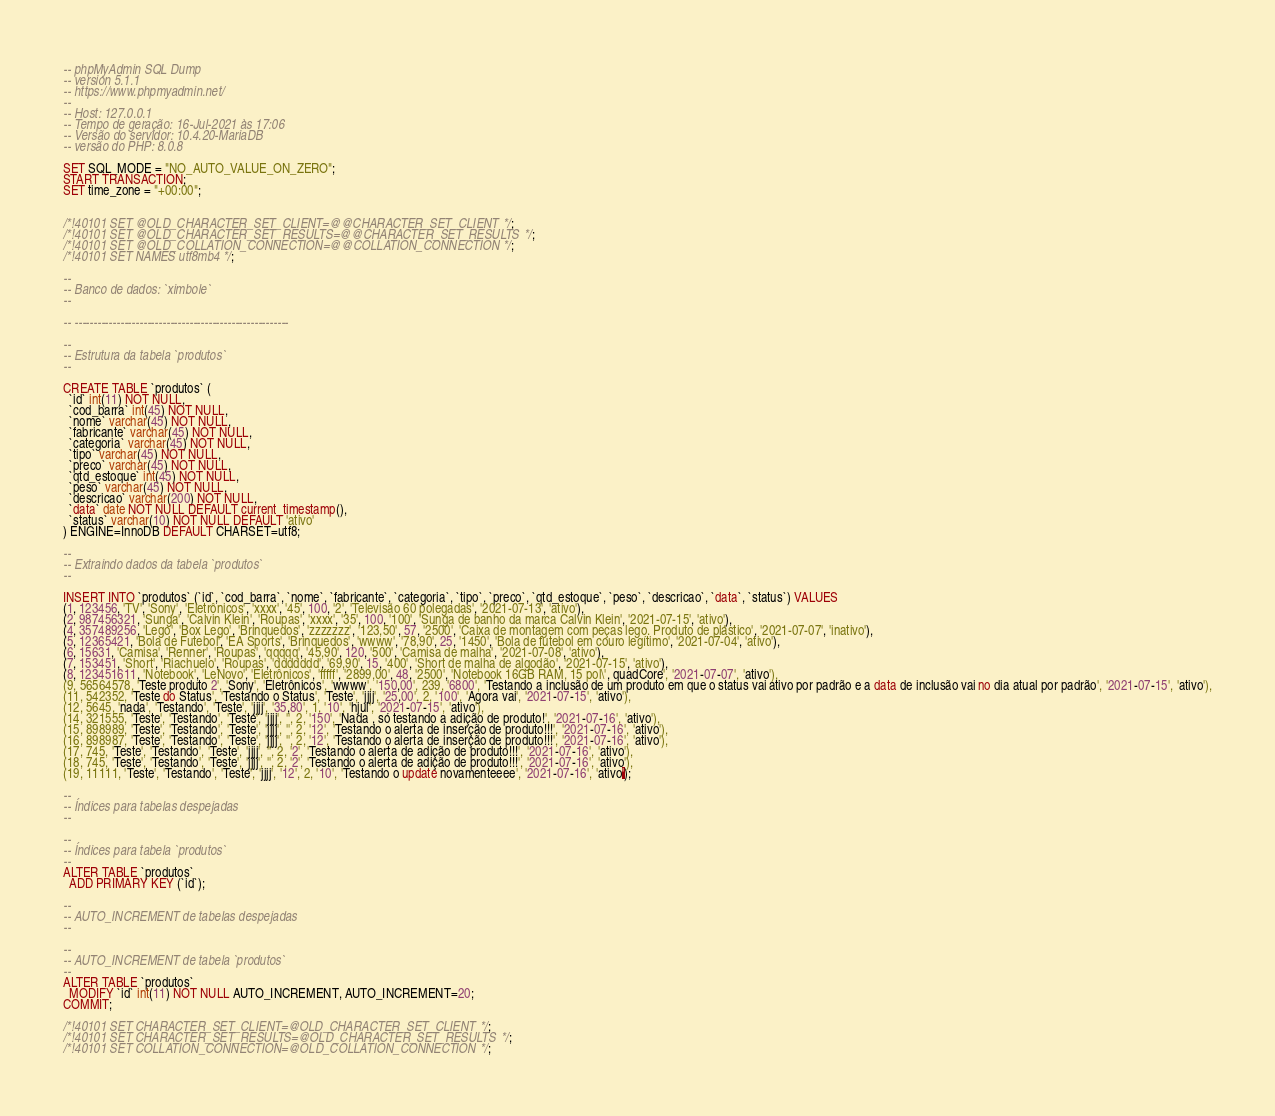Convert code to text. <code><loc_0><loc_0><loc_500><loc_500><_SQL_>-- phpMyAdmin SQL Dump
-- version 5.1.1
-- https://www.phpmyadmin.net/
--
-- Host: 127.0.0.1
-- Tempo de geração: 16-Jul-2021 às 17:06
-- Versão do servidor: 10.4.20-MariaDB
-- versão do PHP: 8.0.8

SET SQL_MODE = "NO_AUTO_VALUE_ON_ZERO";
START TRANSACTION;
SET time_zone = "+00:00";


/*!40101 SET @OLD_CHARACTER_SET_CLIENT=@@CHARACTER_SET_CLIENT */;
/*!40101 SET @OLD_CHARACTER_SET_RESULTS=@@CHARACTER_SET_RESULTS */;
/*!40101 SET @OLD_COLLATION_CONNECTION=@@COLLATION_CONNECTION */;
/*!40101 SET NAMES utf8mb4 */;

--
-- Banco de dados: `ximbole`
--

-- --------------------------------------------------------

--
-- Estrutura da tabela `produtos`
--

CREATE TABLE `produtos` (
  `id` int(11) NOT NULL,
  `cod_barra` int(45) NOT NULL,
  `nome` varchar(45) NOT NULL,
  `fabricante` varchar(45) NOT NULL,
  `categoria` varchar(45) NOT NULL,
  `tipo` varchar(45) NOT NULL,
  `preco` varchar(45) NOT NULL,
  `qtd_estoque` int(45) NOT NULL,
  `peso` varchar(45) NOT NULL,
  `descricao` varchar(200) NOT NULL,
  `data` date NOT NULL DEFAULT current_timestamp(),
  `status` varchar(10) NOT NULL DEFAULT 'ativo'
) ENGINE=InnoDB DEFAULT CHARSET=utf8;

--
-- Extraindo dados da tabela `produtos`
--

INSERT INTO `produtos` (`id`, `cod_barra`, `nome`, `fabricante`, `categoria`, `tipo`, `preco`, `qtd_estoque`, `peso`, `descricao`, `data`, `status`) VALUES
(1, 123456, 'TV', 'Sony', 'Eletrônicos', 'xxxx', '45', 100, '2', 'Televisão 60 polegadas', '2021-07-13', 'ativo'),
(2, 987456321, 'Sunga', 'Calvin Klein', 'Roupas', 'xxxx', '35', 100, '100', 'Sunga de banho da marca Calvin Klein', '2021-07-15', 'ativo'),
(4, 357489256, 'Lego', 'Box Lego', 'Brinquedos', 'zzzzzzz', '123,50', 57, '2500', 'Caixa de montagem com peças lego. Produto de plástico', '2021-07-07', 'inativo'),
(5, 12365421, 'Bola de Futebol', 'EA Sports', 'Brinquedos', 'wwww', '78,90', 25, '1450', 'Bola de futebol em couro legítimo', '2021-07-04', 'ativo'),
(6, 15631, 'Camisa', 'Renner', 'Roupas', 'qqqqq', '45,90', 120, '500', 'Camisa de malha', '2021-07-08', 'ativo'),
(7, 153451, 'Short', 'Riachuelo', 'Roupas', 'ddddddd', '69,90', 15, '400', 'Short de malha de algodão', '2021-07-15', 'ativo'),
(8, 123451611, 'Notebook', 'LeNovo', 'Eletrônicos', 'fffff', '2899,00', 48, '2500', 'Notebook 16GB RAM, 15 pol\', quadCore', '2021-07-07', 'ativo'),
(9, 56564578, 'Teste produto 2', 'Sony', 'Eletrônicos', 'wwww', '150,00', 239, '6800', 'Testando a inclusão de um produto em que o status vai ativo por padrão e a data de inclusão vai no dia atual por padrão', '2021-07-15', 'ativo'),
(11, 542352, 'Teste do Status', 'Testando o Status', 'Teste', 'jjjj', '25,00', 2, '100', 'Agora vai', '2021-07-15', 'ativo'),
(12, 5645, 'nada', 'Testando', 'Teste', 'jjjj', '35,80', 1, '10', 'hjui', '2021-07-15', 'ativo'),
(14, 321555, 'Teste', 'Testando', 'Teste', 'jjjj', '', 2, '150', 'Nada , só testando a adição de produto!', '2021-07-16', 'ativo'),
(15, 898989, 'Teste', 'Testando', 'Teste', 'jjjj', '', 2, '12', 'Testando o alerta de inserção de produto!!!', '2021-07-16', 'ativo'),
(16, 898987, 'Teste', 'Testando', 'Teste', 'jjjj', '', 2, '12', 'Testando o alerta de inserção de produto!!!', '2021-07-16', 'ativo'),
(17, 745, 'Teste', 'Testando', 'Teste', 'jjjj', '', 2, '2', 'Testando o alerta de adição de produto!!!', '2021-07-16', 'ativo'),
(18, 745, 'Teste', 'Testando', 'Teste', 'jjjj', '', 2, '2', 'Testando o alerta de adição de produto!!!', '2021-07-16', 'ativo'),
(19, 11111, 'Teste', 'Testando', 'Teste', 'jjjj', '12', 2, '10', 'Testando o update novamenteeee', '2021-07-16', 'ativo');

--
-- Índices para tabelas despejadas
--

--
-- Índices para tabela `produtos`
--
ALTER TABLE `produtos`
  ADD PRIMARY KEY (`id`);

--
-- AUTO_INCREMENT de tabelas despejadas
--

--
-- AUTO_INCREMENT de tabela `produtos`
--
ALTER TABLE `produtos`
  MODIFY `id` int(11) NOT NULL AUTO_INCREMENT, AUTO_INCREMENT=20;
COMMIT;

/*!40101 SET CHARACTER_SET_CLIENT=@OLD_CHARACTER_SET_CLIENT */;
/*!40101 SET CHARACTER_SET_RESULTS=@OLD_CHARACTER_SET_RESULTS */;
/*!40101 SET COLLATION_CONNECTION=@OLD_COLLATION_CONNECTION */;
</code> 